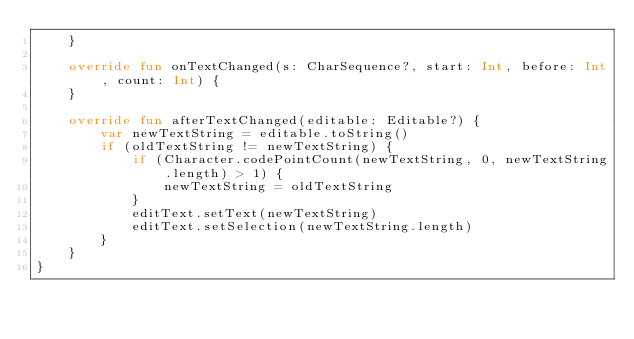<code> <loc_0><loc_0><loc_500><loc_500><_Kotlin_>    }

    override fun onTextChanged(s: CharSequence?, start: Int, before: Int, count: Int) {
    }

    override fun afterTextChanged(editable: Editable?) {
        var newTextString = editable.toString()
        if (oldTextString != newTextString) {
            if (Character.codePointCount(newTextString, 0, newTextString.length) > 1) {
                newTextString = oldTextString
            }
            editText.setText(newTextString)
            editText.setSelection(newTextString.length)
        }
    }
}
</code> 